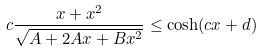<formula> <loc_0><loc_0><loc_500><loc_500>c \frac { x + x ^ { 2 } } { \sqrt { A + 2 A x + B x ^ { 2 } } } \leq \cosh ( c x + d )</formula> 